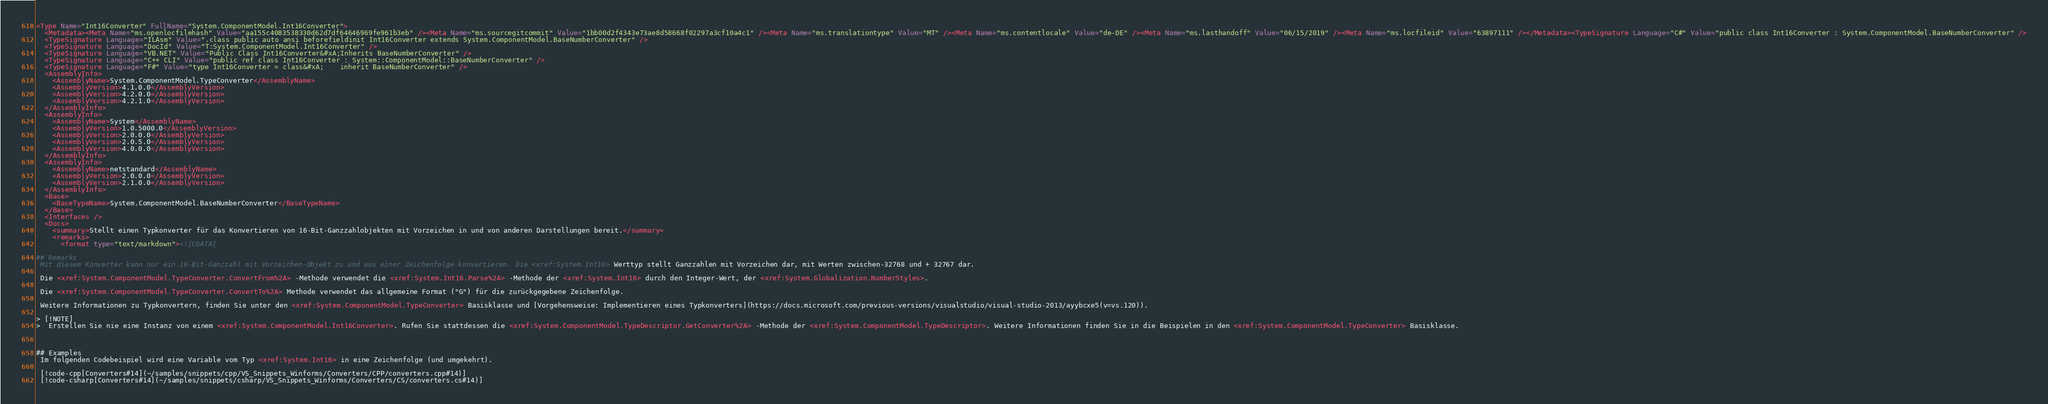Convert code to text. <code><loc_0><loc_0><loc_500><loc_500><_XML_><Type Name="Int16Converter" FullName="System.ComponentModel.Int16Converter">
  <Metadata><Meta Name="ms.openlocfilehash" Value="aa155c4083538330d62d7df64646969fe961b3eb" /><Meta Name="ms.sourcegitcommit" Value="1bb00d2f4343e73ae8d58668f02297a3cf10a4c1" /><Meta Name="ms.translationtype" Value="MT" /><Meta Name="ms.contentlocale" Value="de-DE" /><Meta Name="ms.lasthandoff" Value="06/15/2019" /><Meta Name="ms.locfileid" Value="63897111" /></Metadata><TypeSignature Language="C#" Value="public class Int16Converter : System.ComponentModel.BaseNumberConverter" />
  <TypeSignature Language="ILAsm" Value=".class public auto ansi beforefieldinit Int16Converter extends System.ComponentModel.BaseNumberConverter" />
  <TypeSignature Language="DocId" Value="T:System.ComponentModel.Int16Converter" />
  <TypeSignature Language="VB.NET" Value="Public Class Int16Converter&#xA;Inherits BaseNumberConverter" />
  <TypeSignature Language="C++ CLI" Value="public ref class Int16Converter : System::ComponentModel::BaseNumberConverter" />
  <TypeSignature Language="F#" Value="type Int16Converter = class&#xA;    inherit BaseNumberConverter" />
  <AssemblyInfo>
    <AssemblyName>System.ComponentModel.TypeConverter</AssemblyName>
    <AssemblyVersion>4.1.0.0</AssemblyVersion>
    <AssemblyVersion>4.2.0.0</AssemblyVersion>
    <AssemblyVersion>4.2.1.0</AssemblyVersion>
  </AssemblyInfo>
  <AssemblyInfo>
    <AssemblyName>System</AssemblyName>
    <AssemblyVersion>1.0.5000.0</AssemblyVersion>
    <AssemblyVersion>2.0.0.0</AssemblyVersion>
    <AssemblyVersion>2.0.5.0</AssemblyVersion>
    <AssemblyVersion>4.0.0.0</AssemblyVersion>
  </AssemblyInfo>
  <AssemblyInfo>
    <AssemblyName>netstandard</AssemblyName>
    <AssemblyVersion>2.0.0.0</AssemblyVersion>
    <AssemblyVersion>2.1.0.0</AssemblyVersion>
  </AssemblyInfo>
  <Base>
    <BaseTypeName>System.ComponentModel.BaseNumberConverter</BaseTypeName>
  </Base>
  <Interfaces />
  <Docs>
    <summary>Stellt einen Typkonverter für das Konvertieren von 16-Bit-Ganzzahlobjekten mit Vorzeichen in und von anderen Darstellungen bereit.</summary>
    <remarks>
      <format type="text/markdown"><![CDATA[  
  
## Remarks  
 Mit diesem Konverter kann nur ein 16-Bit-Ganzzahl mit Vorzeichen-Objekt zu und aus einer Zeichenfolge konvertieren. Die <xref:System.Int16> Werttyp stellt Ganzzahlen mit Vorzeichen dar, mit Werten zwischen-32768 und + 32767 dar.  
  
 Die <xref:System.ComponentModel.TypeConverter.ConvertFrom%2A> -Methode verwendet die <xref:System.Int16.Parse%2A> -Methode der <xref:System.Int16> durch den Integer-Wert, der <xref:System.Globalization.NumberStyles>.  
  
 Die <xref:System.ComponentModel.TypeConverter.ConvertTo%2A> Methode verwendet das allgemeine Format ("G") für die zurückgegebene Zeichenfolge.  
  
 Weitere Informationen zu Typkonvertern, finden Sie unter den <xref:System.ComponentModel.TypeConverter> Basisklasse und [Vorgehensweise: Implementieren eines Typkonverters](https://docs.microsoft.com/previous-versions/visualstudio/visual-studio-2013/ayybcxe5(v=vs.120)).  
  
> [!NOTE]
>  Erstellen Sie nie eine Instanz von einem <xref:System.ComponentModel.Int16Converter>. Rufen Sie stattdessen die <xref:System.ComponentModel.TypeDescriptor.GetConverter%2A> -Methode der <xref:System.ComponentModel.TypeDescriptor>. Weitere Informationen finden Sie in die Beispielen in den <xref:System.ComponentModel.TypeConverter> Basisklasse.  
  
   
  
## Examples  
 Im folgenden Codebeispiel wird eine Variable vom Typ <xref:System.Int16> in eine Zeichenfolge (und umgekehrt).  
  
 [!code-cpp[Converters#14](~/samples/snippets/cpp/VS_Snippets_Winforms/Converters/CPP/converters.cpp#14)]
 [!code-csharp[Converters#14](~/samples/snippets/csharp/VS_Snippets_Winforms/Converters/CS/converters.cs#14)]</code> 